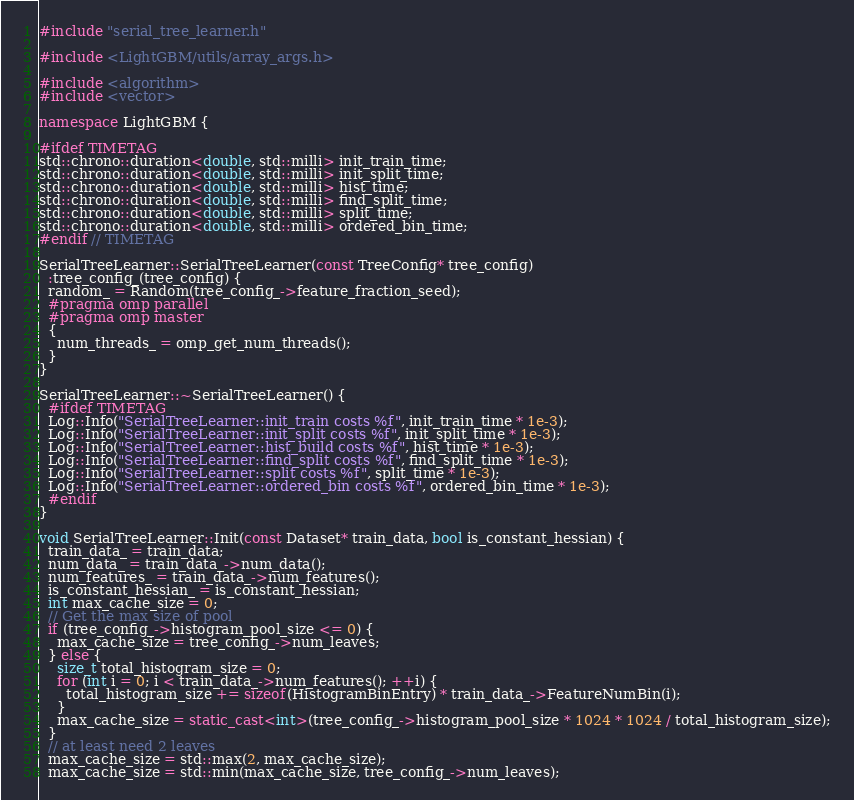<code> <loc_0><loc_0><loc_500><loc_500><_C++_>#include "serial_tree_learner.h"

#include <LightGBM/utils/array_args.h>

#include <algorithm>
#include <vector>

namespace LightGBM {

#ifdef TIMETAG
std::chrono::duration<double, std::milli> init_train_time;
std::chrono::duration<double, std::milli> init_split_time;
std::chrono::duration<double, std::milli> hist_time;
std::chrono::duration<double, std::milli> find_split_time;
std::chrono::duration<double, std::milli> split_time;
std::chrono::duration<double, std::milli> ordered_bin_time;
#endif // TIMETAG

SerialTreeLearner::SerialTreeLearner(const TreeConfig* tree_config)
  :tree_config_(tree_config) {
  random_ = Random(tree_config_->feature_fraction_seed);
  #pragma omp parallel
  #pragma omp master
  {
    num_threads_ = omp_get_num_threads();
  }
}

SerialTreeLearner::~SerialTreeLearner() {
  #ifdef TIMETAG
  Log::Info("SerialTreeLearner::init_train costs %f", init_train_time * 1e-3);
  Log::Info("SerialTreeLearner::init_split costs %f", init_split_time * 1e-3);
  Log::Info("SerialTreeLearner::hist_build costs %f", hist_time * 1e-3);
  Log::Info("SerialTreeLearner::find_split costs %f", find_split_time * 1e-3);
  Log::Info("SerialTreeLearner::split costs %f", split_time * 1e-3);
  Log::Info("SerialTreeLearner::ordered_bin costs %f", ordered_bin_time * 1e-3);
  #endif
}

void SerialTreeLearner::Init(const Dataset* train_data, bool is_constant_hessian) {
  train_data_ = train_data;
  num_data_ = train_data_->num_data();
  num_features_ = train_data_->num_features();
  is_constant_hessian_ = is_constant_hessian;
  int max_cache_size = 0;
  // Get the max size of pool
  if (tree_config_->histogram_pool_size <= 0) {
    max_cache_size = tree_config_->num_leaves;
  } else {
    size_t total_histogram_size = 0;
    for (int i = 0; i < train_data_->num_features(); ++i) {
      total_histogram_size += sizeof(HistogramBinEntry) * train_data_->FeatureNumBin(i);
    }
    max_cache_size = static_cast<int>(tree_config_->histogram_pool_size * 1024 * 1024 / total_histogram_size);
  }
  // at least need 2 leaves
  max_cache_size = std::max(2, max_cache_size);
  max_cache_size = std::min(max_cache_size, tree_config_->num_leaves);
</code> 